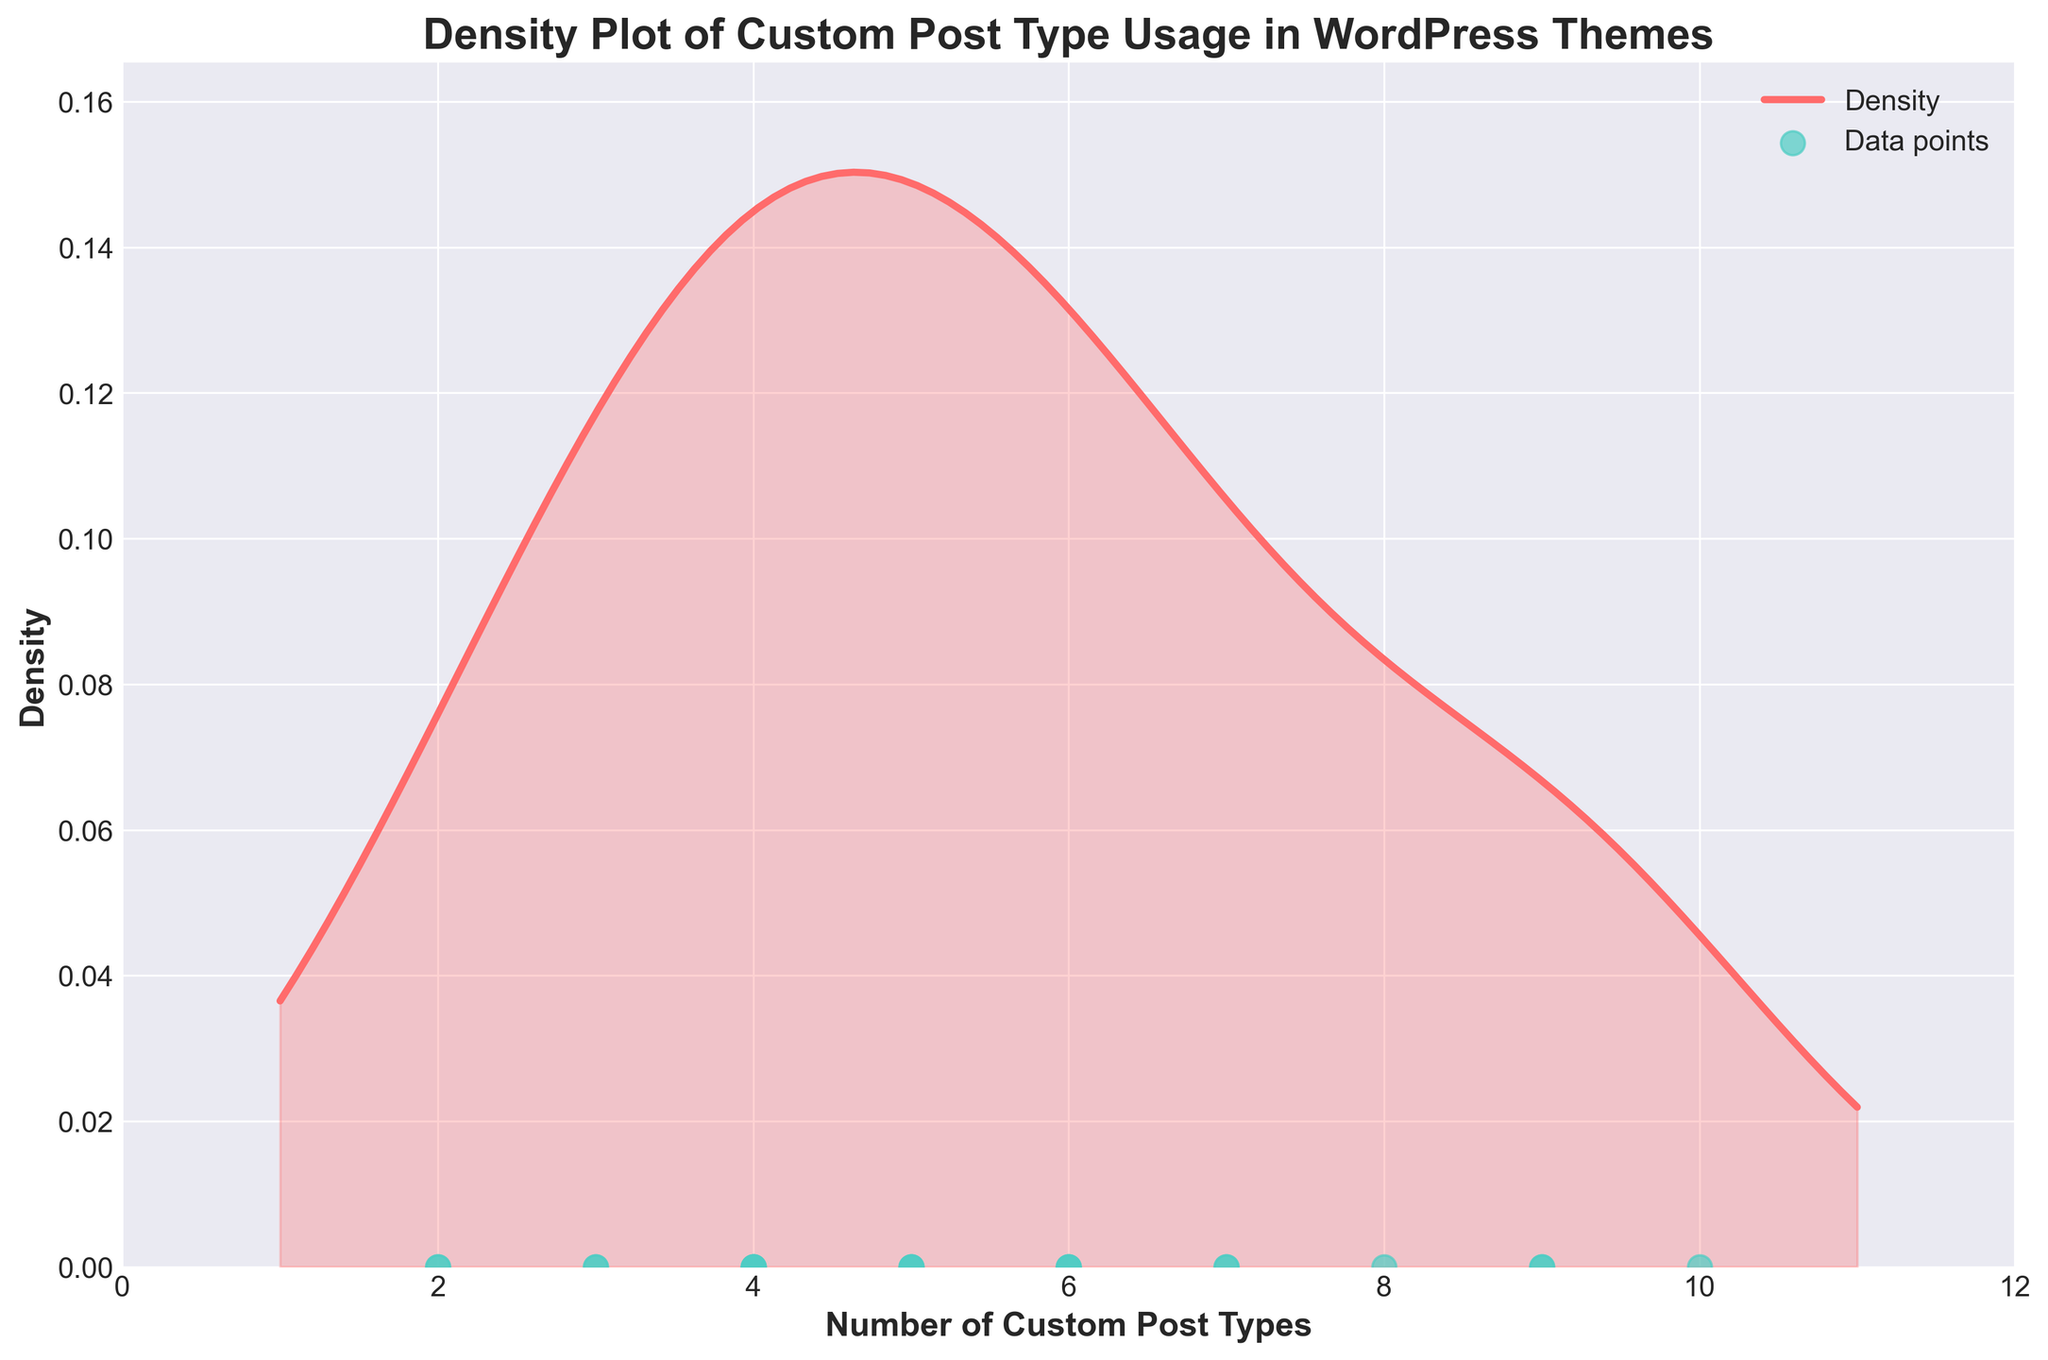what is the title of the figure? The title is located at the top center of the figure and describes what the plot represents. By reading the title provided in the code, we know it is "Density Plot of Custom Post Type Usage in WordPress Themes".
Answer: Density Plot of Custom Post Type Usage in WordPress Themes what are the colors used for the density curve and data points? The density curve and data points use different colors to differentiate between them. According to the description, the density curve is colored '#FF6B6B', which is likely a shade of red, while the data points are colored '#4ECDC4', a shade of green or teal.
Answer: Red for the density curve and green for the data points What is the range of custom post types used in the themes? From the x-axis of the plot, which represents the number of custom post types, we can observe the range of values. Based on the data and the described x-axis, the minimum value is 2 and the maximum value is 10.
Answer: 2 to 10 How many WordPress themes are presented in the figure? By counting the scatter points on the x-axis, each point corresponds to a theme in the dataset. Since there are 20 themes listed in the data, there are 20 scatter points on the plot.
Answer: 20 Which WordPress theme has the highest number of custom post types? The highest peak on the scatter points along the x-axis shows the maximum value, which is 10. Cross-referencing with the data, BeTheme has the highest number of custom post types.
Answer: BeTheme What is the peak density value in the plot? The y-axis of the plot represents the density values. The highest point on the density curve indicates the peak density value, which, according to the code calculation, is slightly above the y value at max.
Answer: Above 0.13 Which themes have fewer custom post types than the median number of custom post types in the dataset? To find the median, list the counts: [2, 2, 3, 3, 4, 4, 4, 4, 5, 5, 5, 5, 6, 6, 6, 7, 7, 8, 9, 9, 10]. The median (middle value) is 5. Themes with fewer than 5 custom post types are: GeneratePress, Sydney, Astra, Neve, OceanWP, Storefront, Salient, Themify Ultra.
Answer: GeneratePress, Sydney, Astra, Neve, OceanWP, Storefront, Salient, Themify Ultra What is the average number of custom post types in the dataset? Calculate the mean by summing all values and dividing by the number of themes: (3 + 7 + 4 + 2 + 9 + 5 + 6 + 4 + 3 + 2 + 8 + 6 + 5 + 7 + 4 + 9 + 10 + 5 + 6 + 4)/20 = 5.3
Answer: 5.3 Which two themes have the same number of custom post types? Observe the scatter points to identify duplicate values along the x-axis. According to the data, the pairs with the same values are: Divi & X Theme (7), Kadence & Enfold (6), Blocksy & Newspaper (5), OceanWP & Storefront (4), Astra & Neve (3), GeneratePress & Sydney (2).
Answer: Divi & X Theme, Kadence & Enfold Is there any WordPress theme that uses exactly the median number of custom post types? Median value calculated is 5. By checking the scatter points aligned with 5 and cross-referencing with the data, Storefront, Jupiter, Blocksy, and Newspaper fall exactly on the median.
Answer: Storefront, Jupiter, Blocksy, Newspaper 